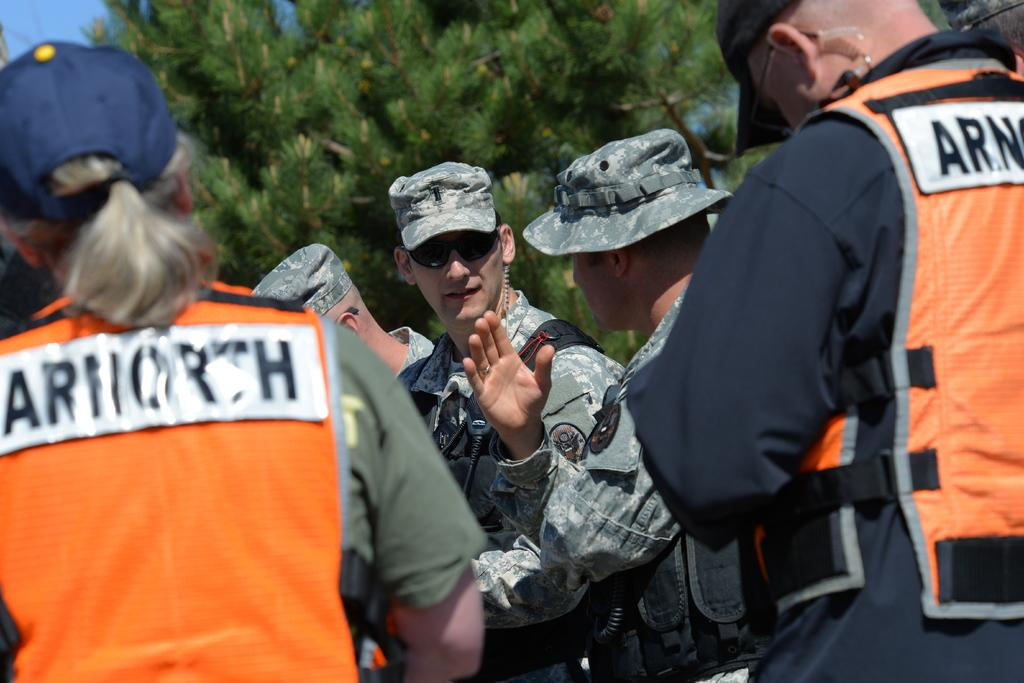What type of people can be seen in the image? There are soldiers in the image. Can you describe the individuals wearing orange jackets? There are two persons wearing orange jackets in the image, and they are standing on either side of the soldiers. What is visible in the background of the image? There are trees in the background of the image. What type of tent can be seen in the image? There is no tent present in the image. Can you describe the voice of the soldier in the image? The image is a still picture, so there is no voice or sound present. 